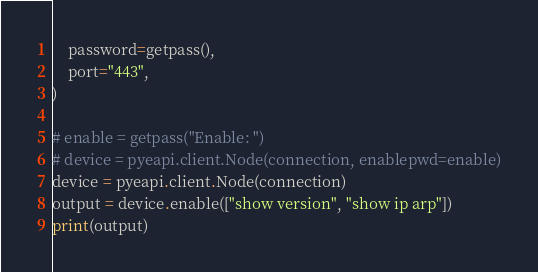Convert code to text. <code><loc_0><loc_0><loc_500><loc_500><_Python_>    password=getpass(),
    port="443",
)

# enable = getpass("Enable: ")
# device = pyeapi.client.Node(connection, enablepwd=enable)
device = pyeapi.client.Node(connection)
output = device.enable(["show version", "show ip arp"])
print(output)
</code> 